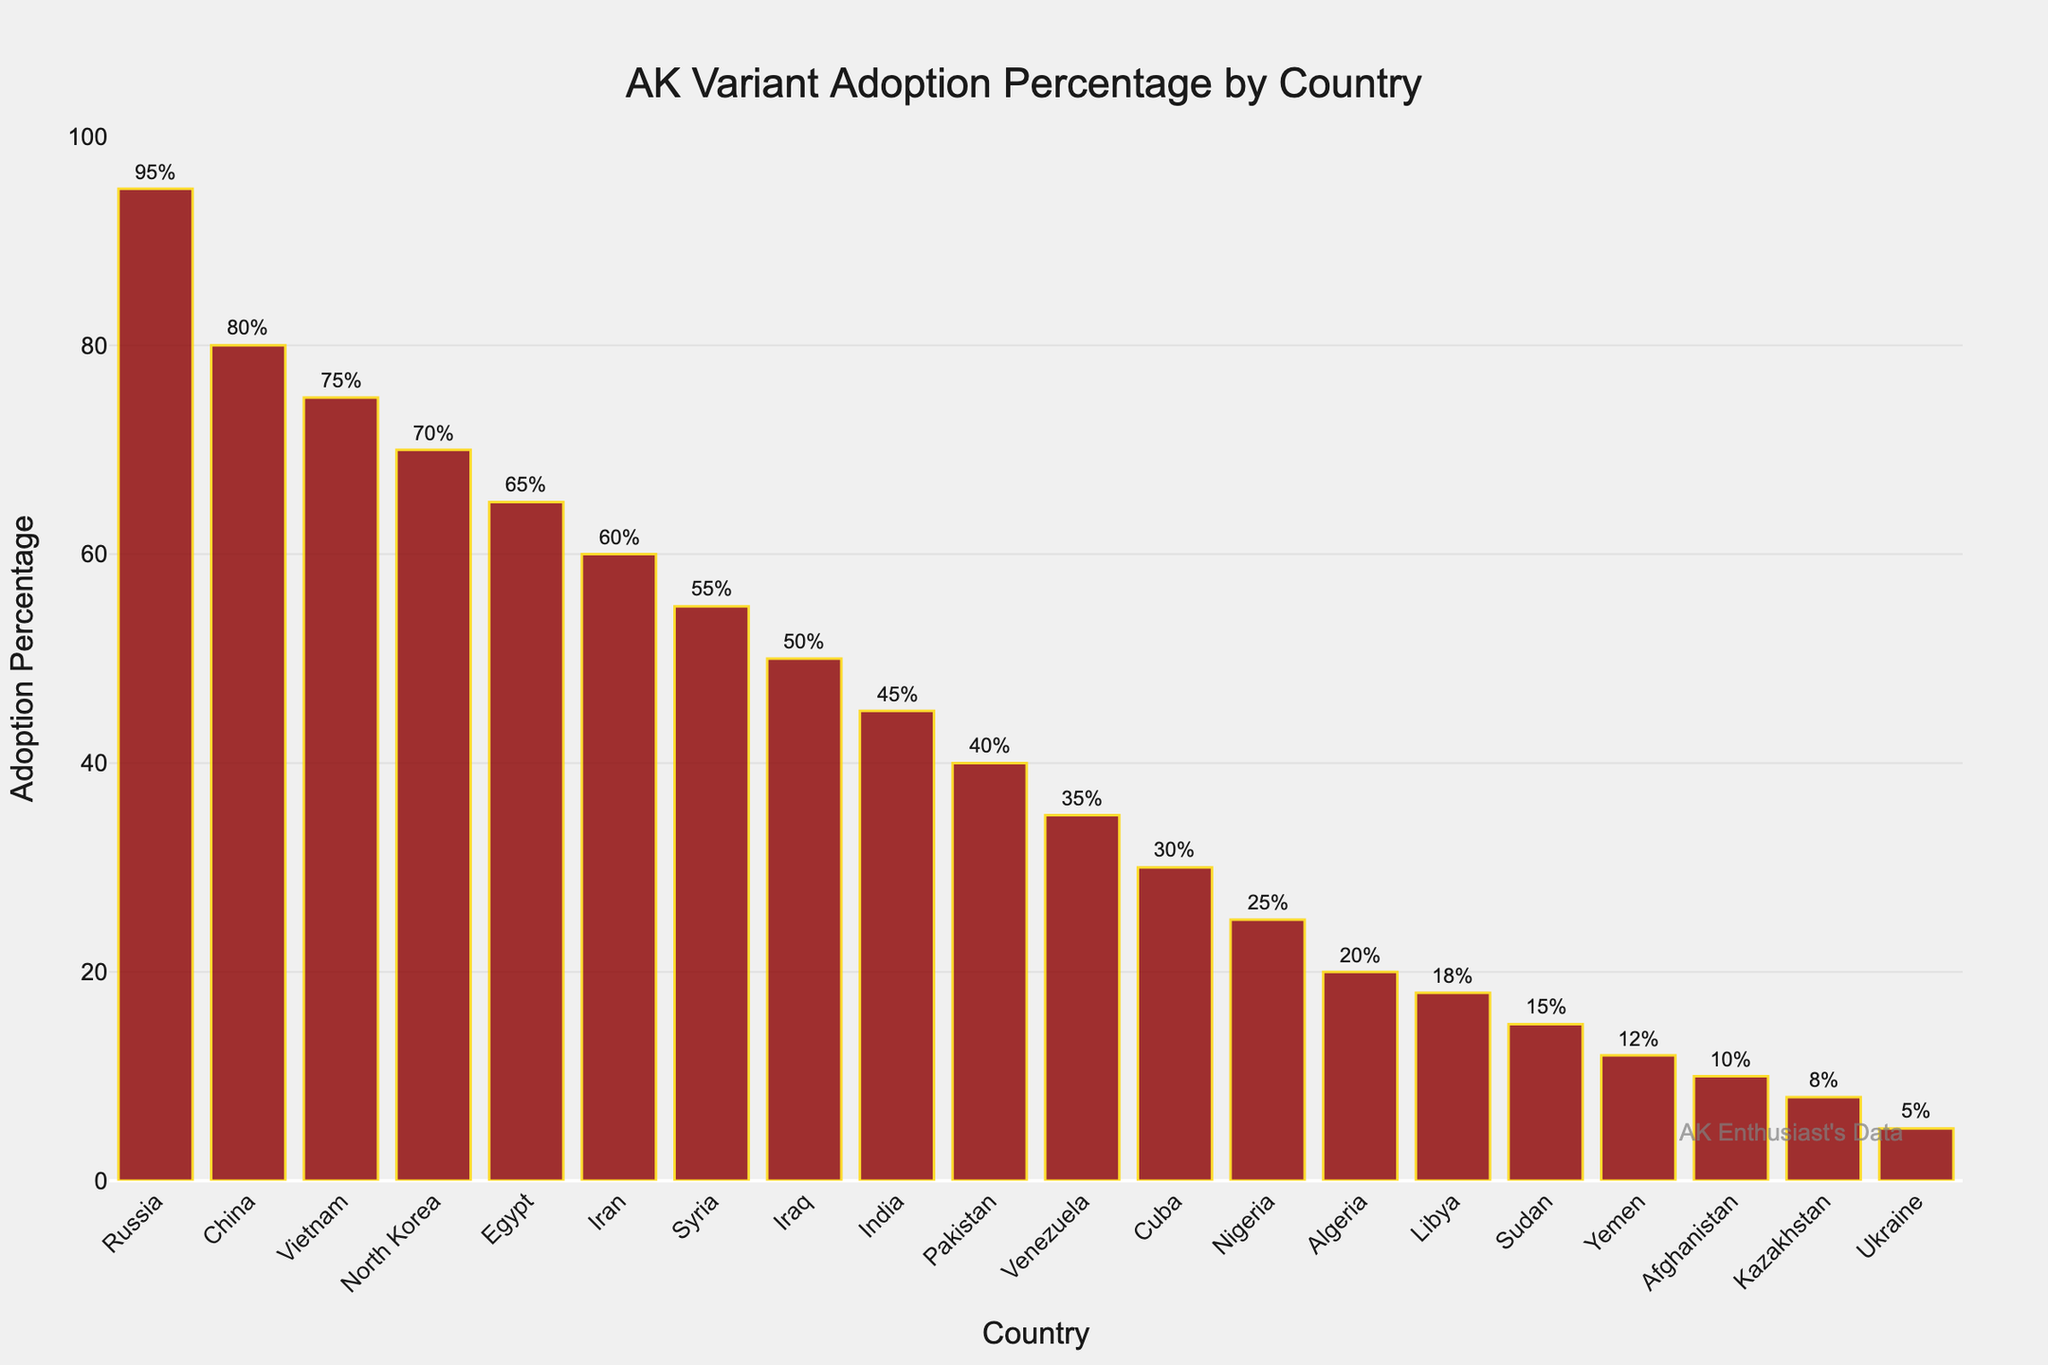What is the country with the highest AK Variant Adoption Percentage? By looking at the bar chart, the tallest bar represents the country with the highest AK Variant Adoption Percentage. The bar corresponding to Russia is the tallest, indicating Russia has the highest adoption percentage.
Answer: Russia What is the difference in AK Variant Adoption Percentage between Russia and China? First, identify the adoption percentages for Russia and China from the chart, which are 95% and 80%, respectively. Then, calculate the difference: 95% - 80% = 15%.
Answer: 15% Which country has a greater AK Variant Adoption Percentage, Egypt or Iran? Compare the heights of the bars corresponding to Egypt and Iran. Egypt's bar is taller, indicating Egypt has a greater adoption percentage.
Answer: Egypt What is the average AK Variant Adoption Percentage for the top 3 countries? Identify the top 3 countries from the chart (Russia, China, and Vietnam) and their adoption percentages (95%, 80%, and 75%). Then, calculate the average: (95 + 80 + 75) / 3 = 83.33%.
Answer: 83.33% Which country has an adoption percentage closest to 50%? Locate the bar closest to the 50% mark on the y-axis and find its corresponding country. Iraq, with 50%, is closest to this mark.
Answer: Iraq What is the sum of the AK Variant Adoption Percentages for North Korea and Egypt? Identify the adoption percentages for North Korea (70%) and Egypt (65%). Then, calculate the sum: 70% + 65% = 135%.
Answer: 135% How many countries have an AK Variant Adoption Percentage of 25% or less? Count the bars that reach up to or below the 25% mark on the y-axis. These countries from the chart are Nigeria (25%), Algeria (20%), Libya (18%), Sudan (15%), Yemen (12%), Afghanistan (10%), Kazakhstan (8%), and Ukraine (5%). There are 8 such countries.
Answer: 8 Which country has a lesser AK Variant Adoption Percentage, Sudan or Afghanistan? Compare the heights of the bars representing Sudan and Afghanistan. Afghanistan's bar is shorter, indicating a lesser adoption percentage.
Answer: Afghanistan What is the visual difference between the adoption percentages of Cuba and Venezuela on the chart? Observe the heights of the bars corresponding to Cuba (30%) and Venezuela (35%). Venezuela's bar is slightly taller than Cuba's, indicating Venezuela has a higher adoption percentage.
Answer: Venezuela Which countries have an AK Variant Adoption Percentage between 50% and 70%? Identify the bars between the 50% and 70% marks on the y-axis. These countries are Syria (55%) and Iraq (50%).
Answer: Syria, Iraq 